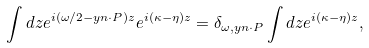<formula> <loc_0><loc_0><loc_500><loc_500>\int d z e ^ { i ( \omega / 2 - y n \cdot P ) z } e ^ { i ( \kappa - \eta ) z } = \delta _ { \omega , y n \cdot P } \int d z e ^ { i ( \kappa - \eta ) z } ,</formula> 